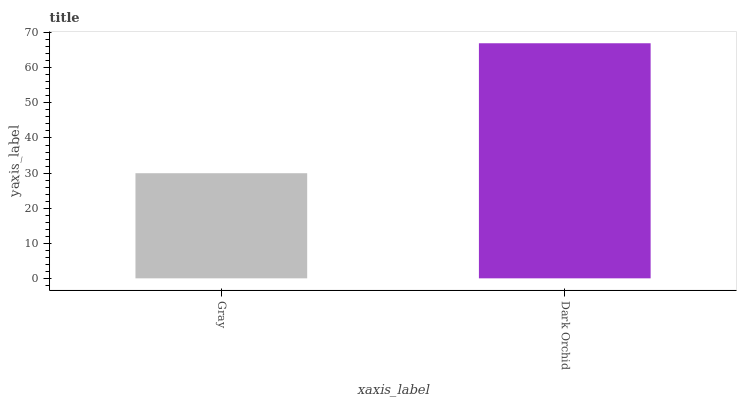Is Dark Orchid the maximum?
Answer yes or no. Yes. Is Dark Orchid the minimum?
Answer yes or no. No. Is Dark Orchid greater than Gray?
Answer yes or no. Yes. Is Gray less than Dark Orchid?
Answer yes or no. Yes. Is Gray greater than Dark Orchid?
Answer yes or no. No. Is Dark Orchid less than Gray?
Answer yes or no. No. Is Dark Orchid the high median?
Answer yes or no. Yes. Is Gray the low median?
Answer yes or no. Yes. Is Gray the high median?
Answer yes or no. No. Is Dark Orchid the low median?
Answer yes or no. No. 